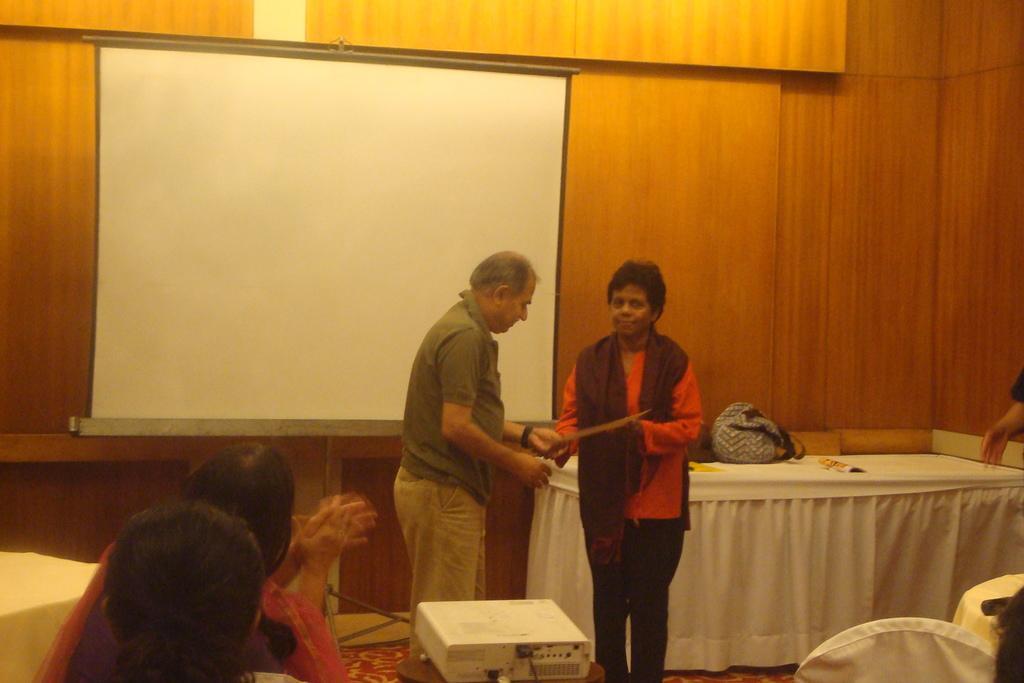In one or two sentences, can you explain what this image depicts? In this image I can see a person wearing t shirt and pant and another person wearing red and black dress are standing and holding an object in their hands. I can see few other persons and a white colored projector. In the background I can see a white colored screen, the brown colored wall and a table on which I can see few objects. 